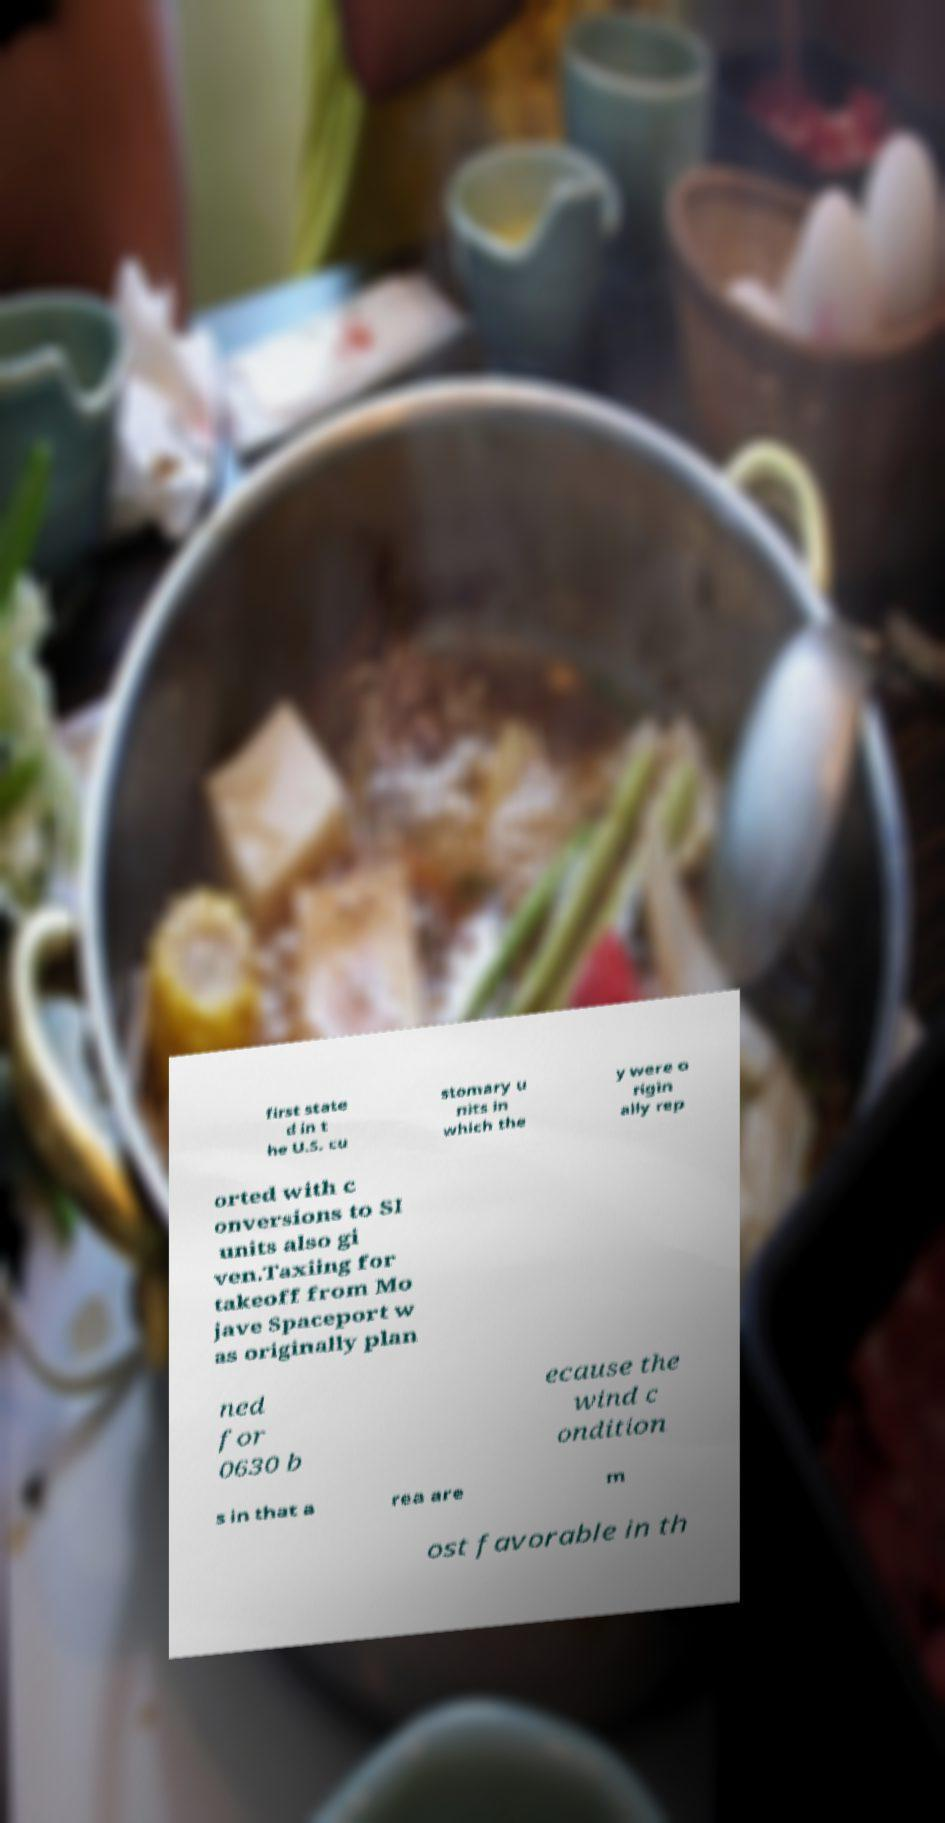Could you assist in decoding the text presented in this image and type it out clearly? first state d in t he U.S. cu stomary u nits in which the y were o rigin ally rep orted with c onversions to SI units also gi ven.Taxiing for takeoff from Mo jave Spaceport w as originally plan ned for 0630 b ecause the wind c ondition s in that a rea are m ost favorable in th 